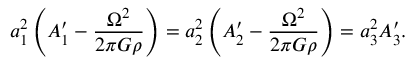Convert formula to latex. <formula><loc_0><loc_0><loc_500><loc_500>a _ { 1 } ^ { 2 } \left ( A _ { 1 } ^ { \prime } - \frac { \Omega ^ { 2 } } { 2 \pi G \rho } \right ) = a _ { 2 } ^ { 2 } \left ( A _ { 2 } ^ { \prime } - \frac { \Omega ^ { 2 } } { 2 \pi G \rho } \right ) = a _ { 3 } ^ { 2 } A _ { 3 } ^ { \prime } .</formula> 